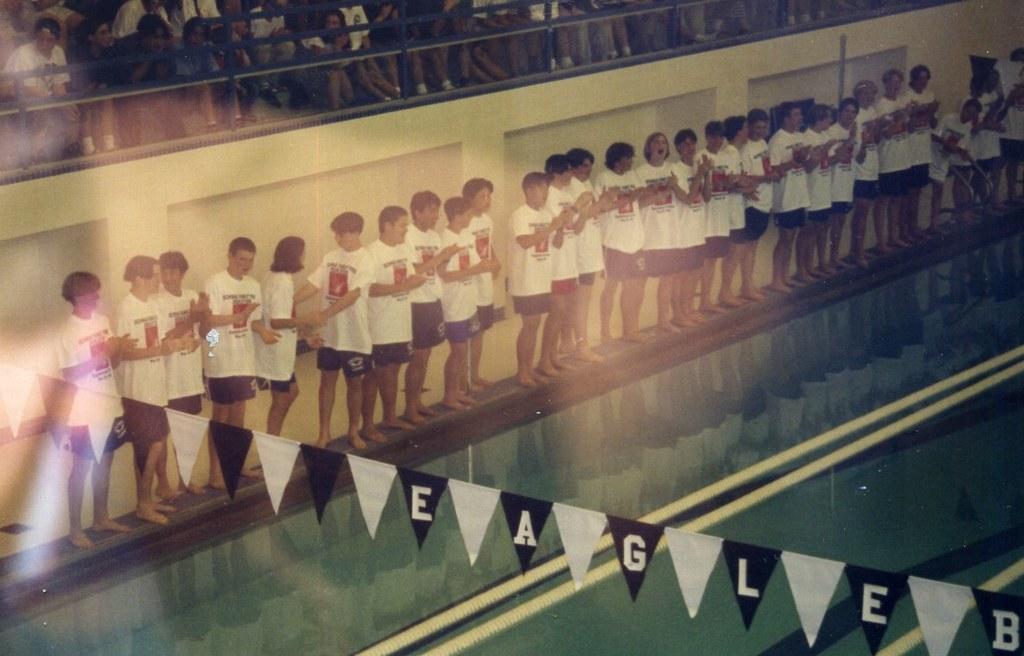Can you describe this image briefly? In the image there are many people with white t-shirts and black shorts. In front of them there is water. There are decorative flags which are black and white color and there are few alphabets on it. At the top of the image there is a fencing. Behind the fencing there are few people. 